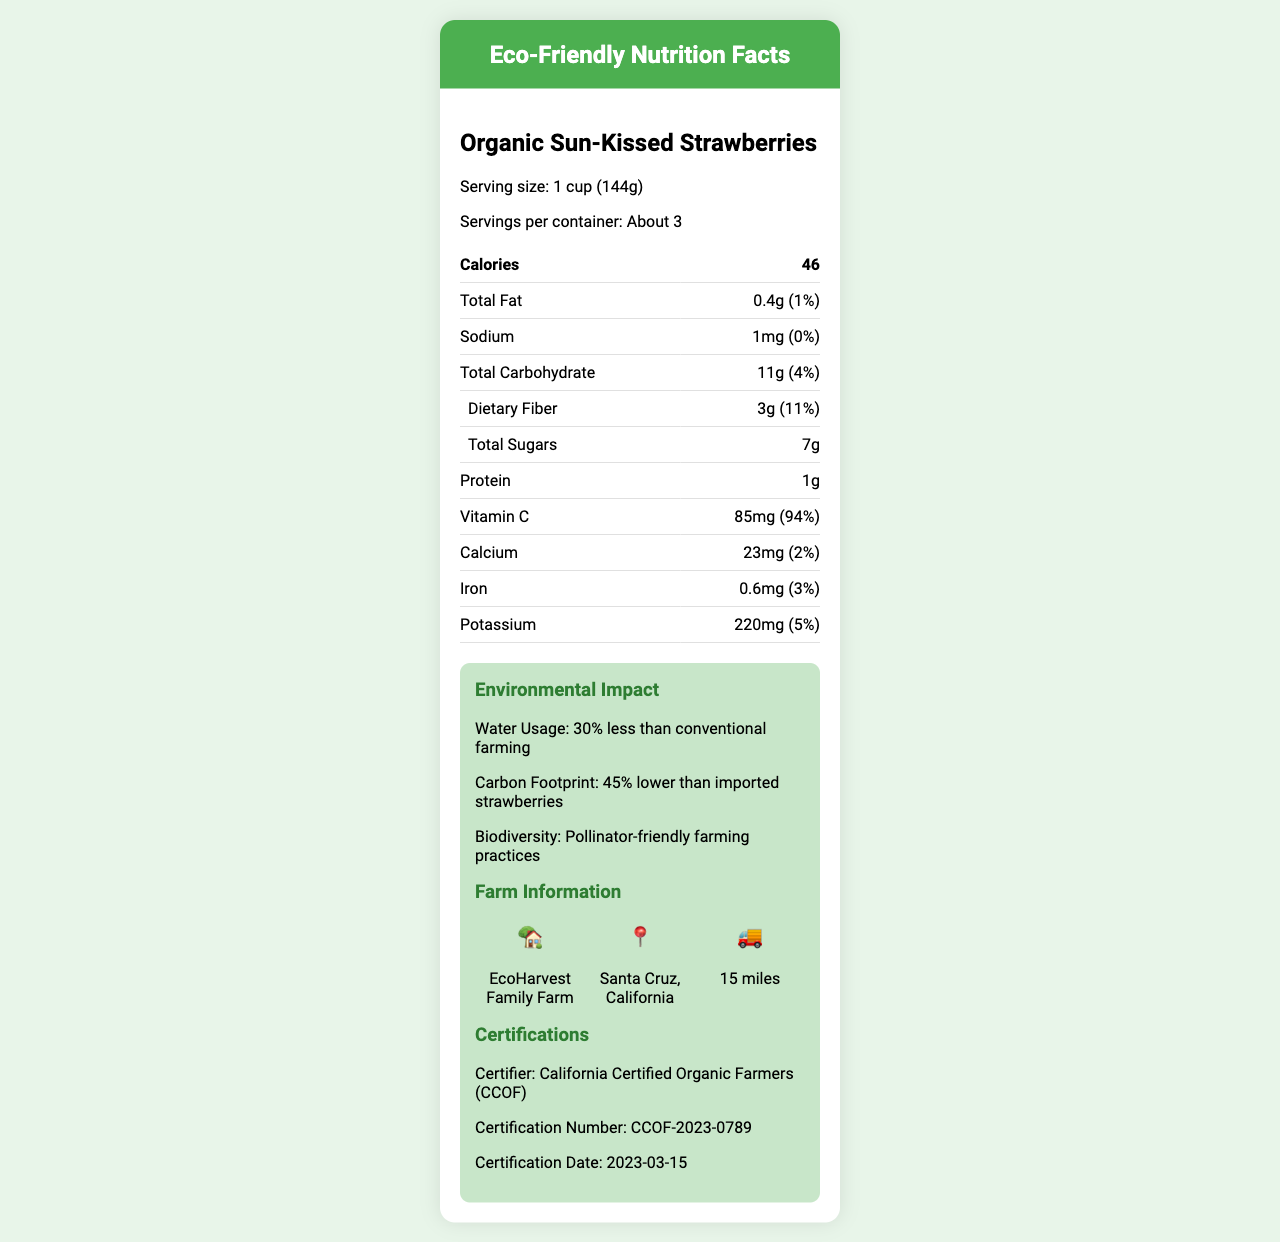what is the serving size? The serving size is clearly stated as "1 cup (144g)" in the section listing nutritional information.
Answer: 1 cup (144g) how many servings are in this container? The document mentions that there are "About 3" servings per container.
Answer: About 3 what is the amount of calories per serving? The number of calories per serving is listed as 46.
Answer: 46 how much dietary fiber is in one serving? The amount of dietary fiber per serving is listed as 3g.
Answer: 3g which vitamin is present in the highest amount per serving, and what is its daily value percentage? The document states that Vitamin C amount per serving is 85mg, which is 94% of the daily value.
Answer: Vitamin C, 94% who certified the pesticide-free status of the strawberries? The certification information shows that California Certified Organic Farmers (CCOF) certified the strawberries.
Answer: California Certified Organic Farmers (CCOF) what is the certification number for the pesticide-free status? The certification number provided under the pesticide-free certification is CCOF-2023-0789.
Answer: CCOF-2023-0789 what is the water usage impact of these strawberries compared to conventional farming? The document states that the water usage for these strawberries is 30% less than conventional farming.
Answer: 30% less where is EcoHarvest Family Farm located? The location of the farm is given as Santa Cruz, California.
Answer: Santa Cruz, California what is the seasonal availability of Organic Sun-Kissed Strawberries? The seasonal availability section specifies the months from May to September.
Answer: May to September which farming practice supports biodiversity as per the document? The document mentions that the biodiversity support comes from pollinator-friendly farming practices.
Answer: Pollinator-friendly farming practices what is the main idea of the document? The document comprehensively details the nutritional facts, environmental impact, farm information, and certification details of Organic Sun-Kissed Strawberries, highlighting their organic production and lower environmental impact.
Answer: Description of the nutritional, environmental, and certification details of Organic Sun-Kissed Strawberries, emphasizing their organic nature, nutritional benefits, and sustainable farming practices. how much potassium is there per serving, and what is its daily value percentage? A. 110mg, 2% B. 150mg, 3% C. 220mg, 5% D. 300mg, 7% The document lists the potassium amount per serving as 220mg, which is 5% of the daily value.
Answer: C what is the recommended way to store these strawberries? A. Keep in a dry place B. Refrigerate and consume within 5 days C. Freeze for long-term storage D. Store at room temperature The document recommends refrigerating the strawberries and consuming them within 5 days for optimal freshness.
Answer: B are the strawberries rich in antioxidants? The document states that the strawberries are high in antioxidants, particularly anthocyanins and ellagic acid.
Answer: Yes is the distance from the farm to the market more than 20 miles? The document specifies that the distance to market is 15 miles, which is not more than 20 miles.
Answer: No did the certification happen in 2022? The certification date listed is 2023-03-15, indicating that it did not happen in 2022.
Answer: No what is the carbon footprint reduction compared to imported strawberries? The document mentions that these strawberries have a 45% lower carbon footprint compared to imported strawberries.
Answer: 45% lower how many grams of sugars are there in one serving of strawberries? The document lists the total sugars per serving as 7g.
Answer: 7g can strawberries prevent heart diseases based on the information in the document? The document does not provide any information or make any claims about the potential of strawberries to prevent heart diseases.
Answer: Not enough information 